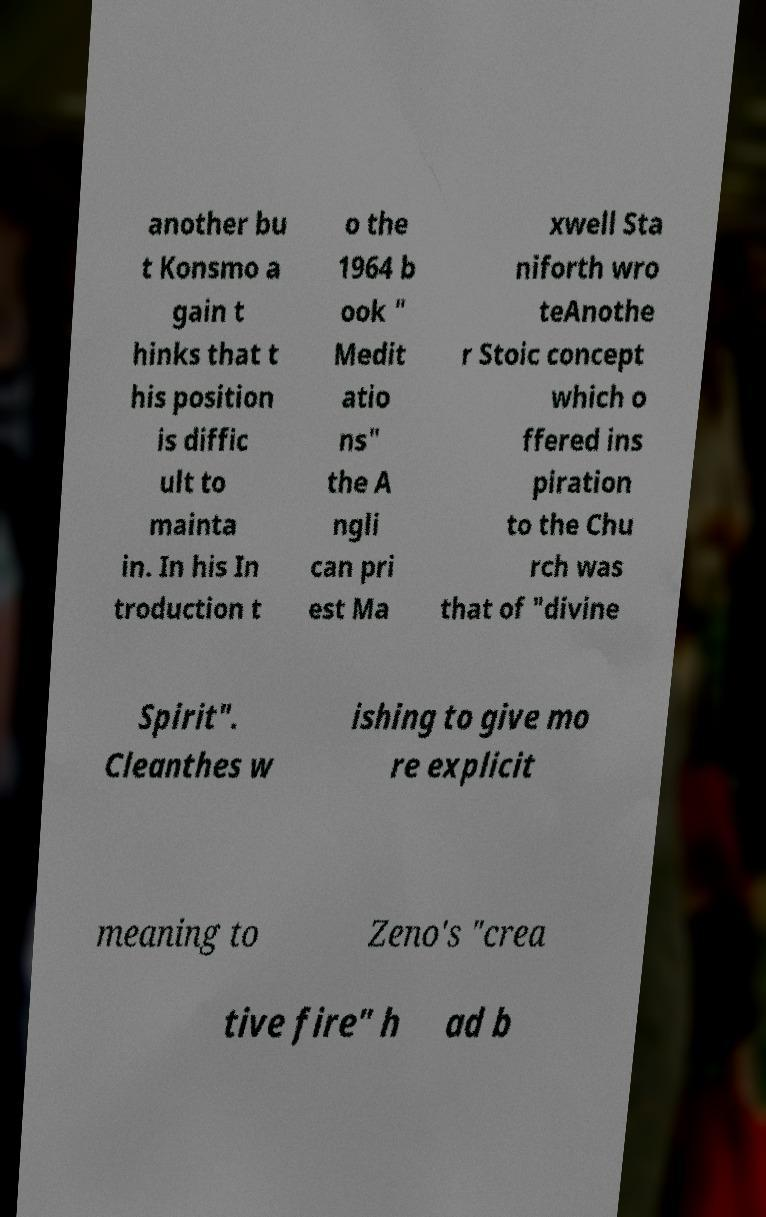Please read and relay the text visible in this image. What does it say? another bu t Konsmo a gain t hinks that t his position is diffic ult to mainta in. In his In troduction t o the 1964 b ook " Medit atio ns" the A ngli can pri est Ma xwell Sta niforth wro teAnothe r Stoic concept which o ffered ins piration to the Chu rch was that of "divine Spirit". Cleanthes w ishing to give mo re explicit meaning to Zeno's "crea tive fire" h ad b 